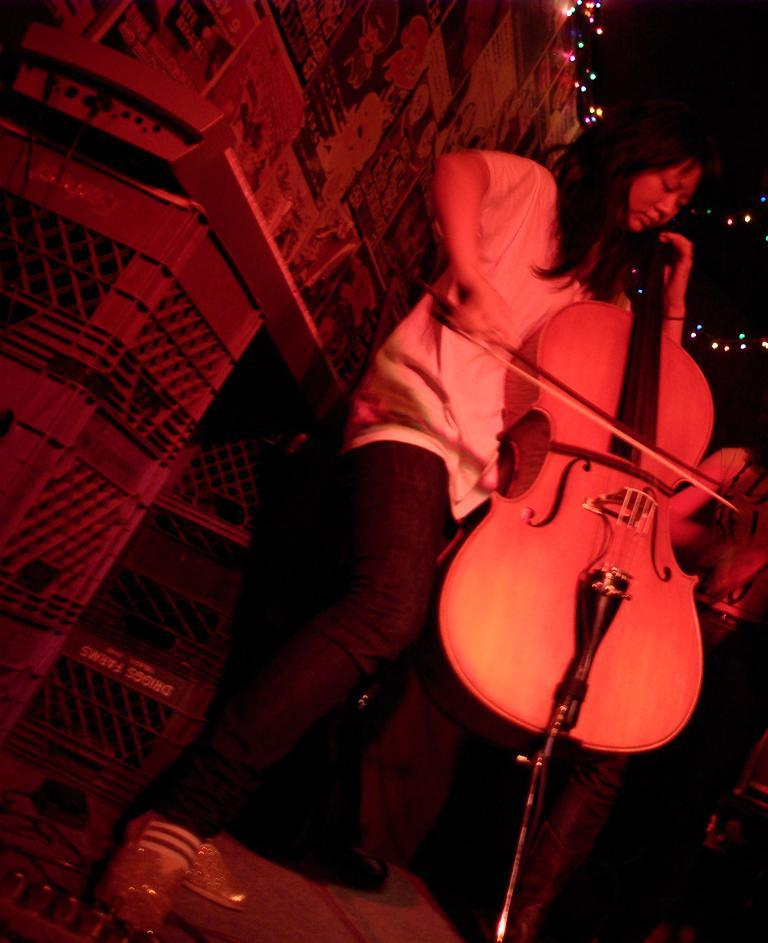What is the main subject of the image? The main subject of the image is a woman. What is the woman doing in the image? The woman is playing a musical instrument in the image. What can be seen in the background of the image? There are lights visible in the background of the image. What is the end of the story about the woman in the image? There is no story about the woman in the image, so there is no end to discuss. 